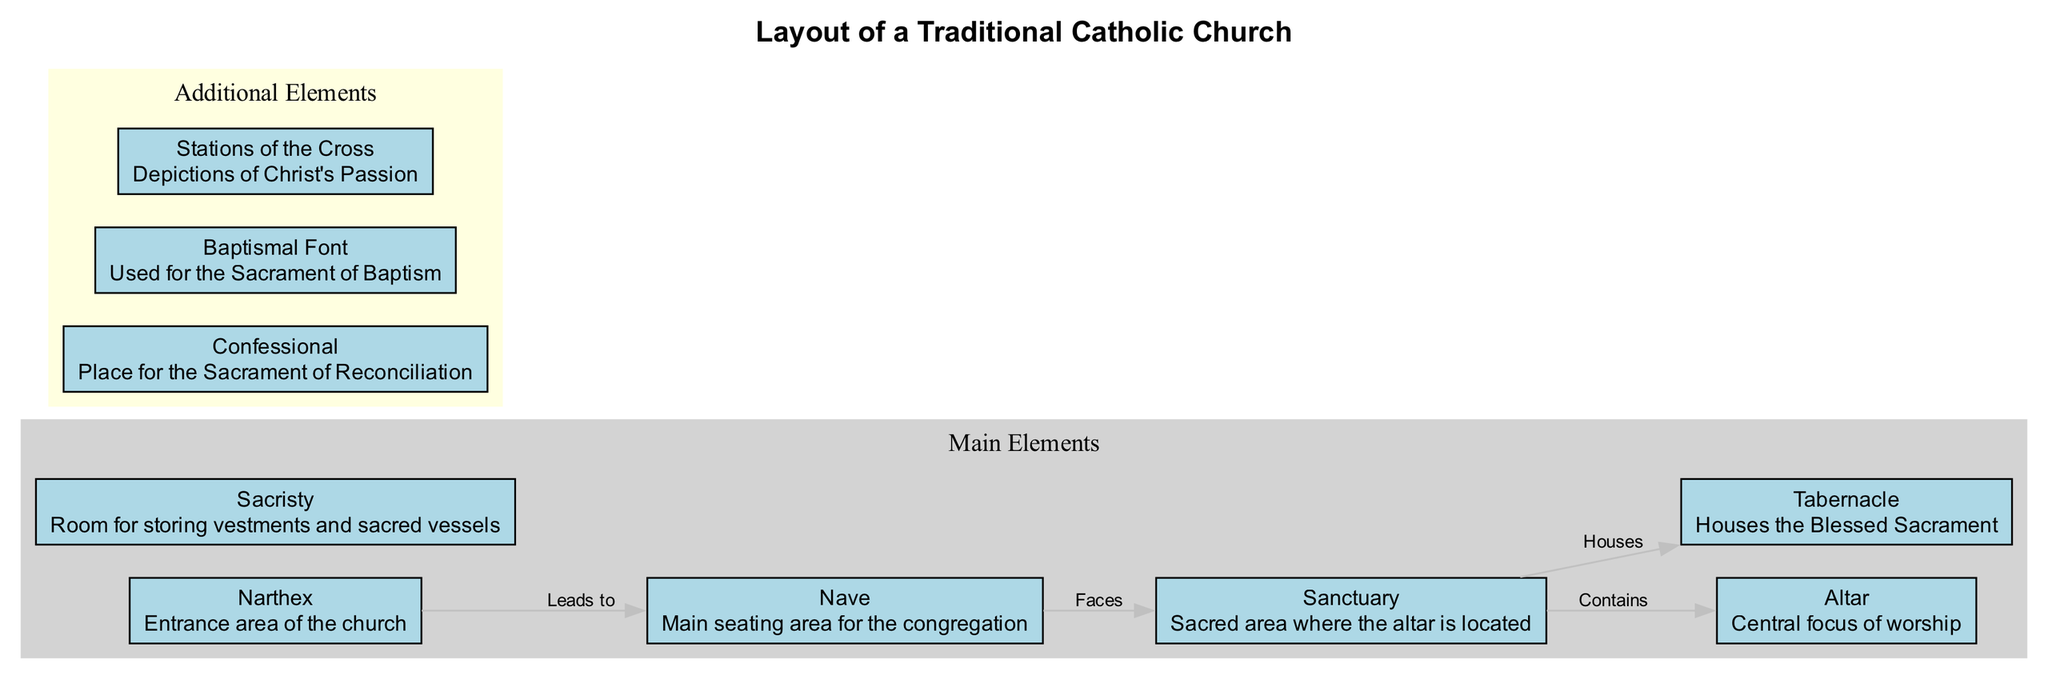What is the entrance area of the church called? The diagram labels the area at the front of the church as the "Narthex," which is described as the entrance area.
Answer: Narthex What area contains the altar? According to the diagram, the "Sanctuary" is indicated as the sacred area, which contains the altar.
Answer: Sanctuary How many main elements are listed in the diagram? Counting the nodes in the "Main Elements" section of the diagram, there are six main elements identified: Narthex, Nave, Sanctuary, Altar, Tabernacle, and Sacristy.
Answer: 6 What element houses the Blessed Sacrament? The diagram directly indicates that the "Tabernacle" is the element that houses the Blessed Sacrament.
Answer: Tabernacle Which area leads to the Nave? The relationship depicted in the diagram shows that the "Narthex" leads to the "Nave."
Answer: Narthex What is the purpose of the Confessional? The diagram describes the "Confessional" as the place for the Sacrament of Reconciliation, indicating its intended use.
Answer: Sacrament of Reconciliation Where is the main seating area for the congregation? The diagram clearly labels the "Nave" as the main seating area for the congregation, detailing its purpose in the structure.
Answer: Nave What relationship exists between the Nave and the Sanctuary? The diagram states that the Nave faces the Sanctuary, establishing a directional relationship between the two areas.
Answer: Faces How many additional elements are included in the diagram? Assessing the "Additional Elements" section, there are three additional elements identified: Confessional, Baptismal Font, and Stations of the Cross.
Answer: 3 